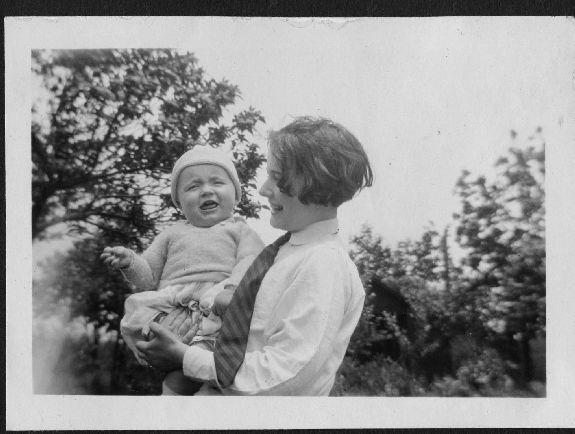What is the person in white doing?
Be succinct. Holding baby. How many kids are sitting?
Quick response, please. 1. Is the lady's hair long?
Quick response, please. No. Does the child have on a helmet or hat?
Quick response, please. Hat. What kind of chair is the baby sitting in?
Answer briefly. None. How many trees can be seen?
Be succinct. 4. What kind of weather is she dressed for?
Give a very brief answer. Winter. Is the baby crying?
Answer briefly. Yes. How many people in this photo are wearing hats?
Quick response, please. 1. What is on the lad's head?
Write a very short answer. Hat. Is this a collage?
Keep it brief. No. What color shirt is the boy wearing?
Quick response, please. White. What is the woman wearing on her neck?
Short answer required. Tie. Who is wearing the hat?
Answer briefly. Baby. Are they both wearing ties?
Keep it brief. No. What is the baby thinking?
Keep it brief. Sad. Is the little boy wearing mittens?
Short answer required. No. What pattern are the boys pants?
Write a very short answer. Solid. Are there any elderly people in the picture?
Write a very short answer. No. What color are the trees?
Be succinct. Green. 